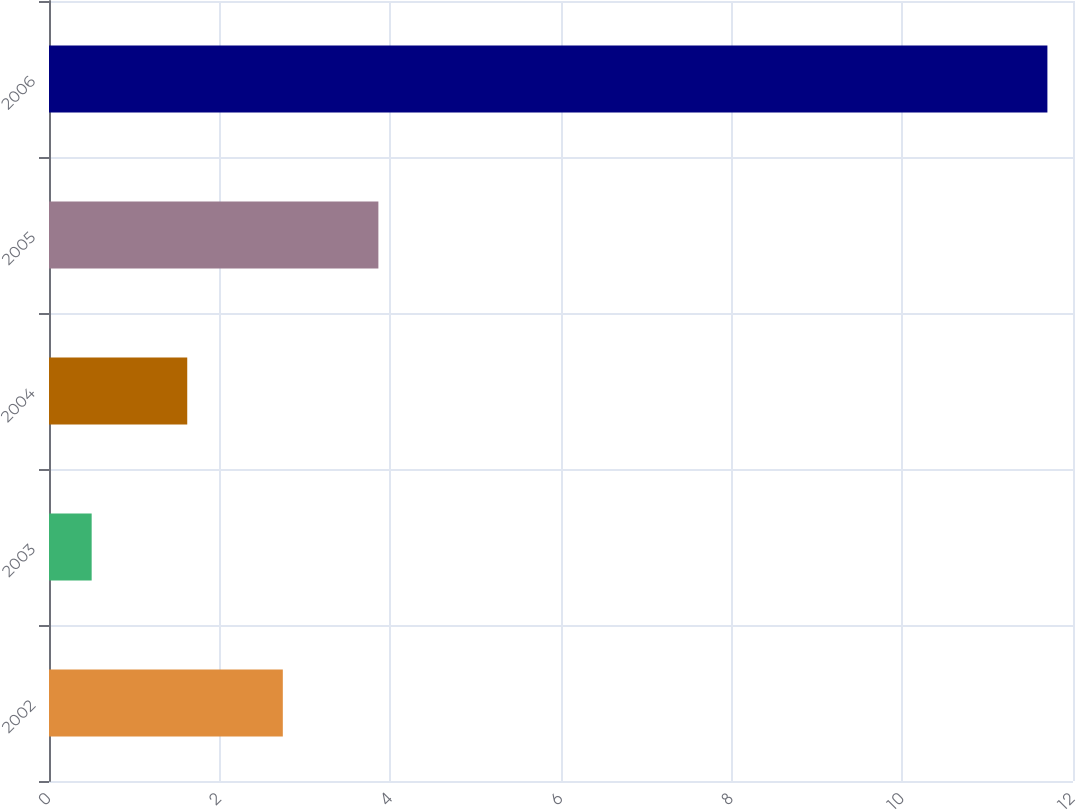Convert chart to OTSL. <chart><loc_0><loc_0><loc_500><loc_500><bar_chart><fcel>2002<fcel>2003<fcel>2004<fcel>2005<fcel>2006<nl><fcel>2.74<fcel>0.5<fcel>1.62<fcel>3.86<fcel>11.7<nl></chart> 